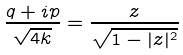Convert formula to latex. <formula><loc_0><loc_0><loc_500><loc_500>\frac { q + i p } { \sqrt { 4 k } } = \frac { z } { \sqrt { 1 - | z | ^ { 2 } } }</formula> 